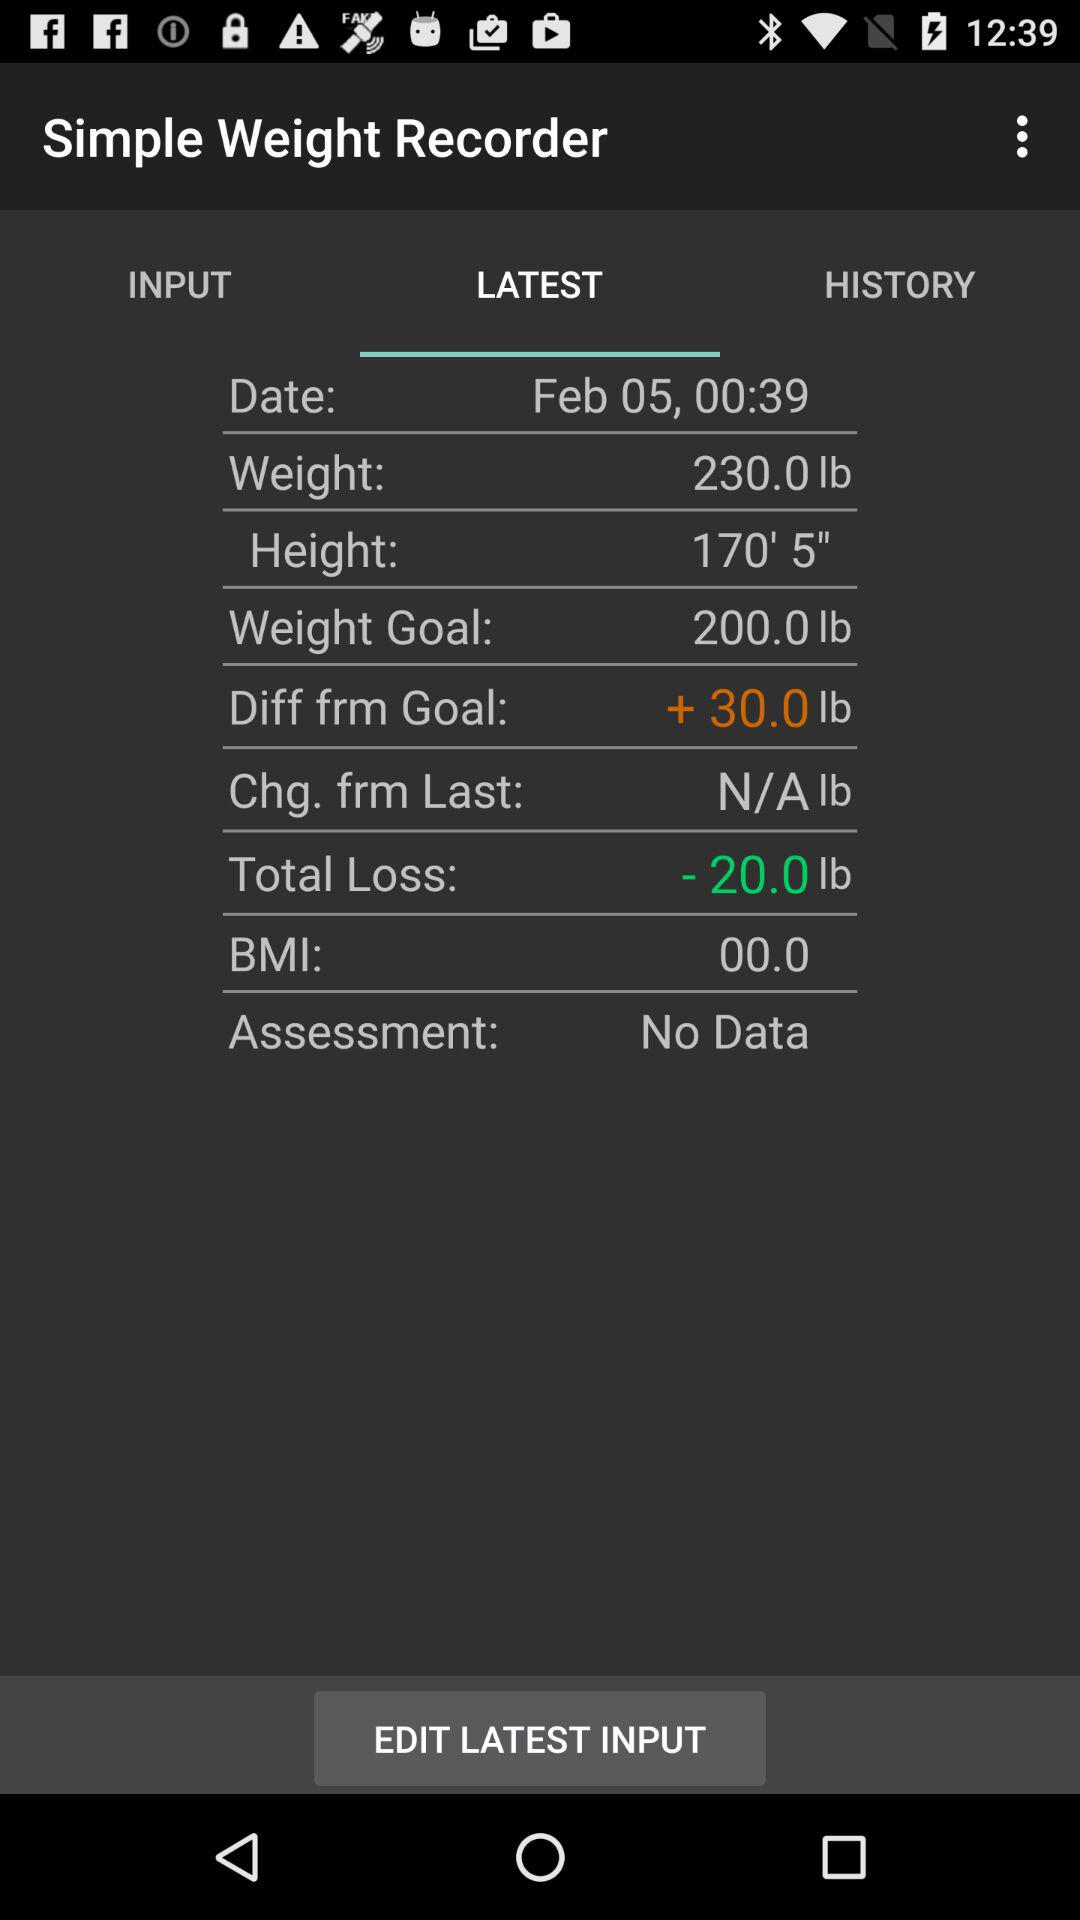Which tab is selected? The selected tab is "LATEST". 